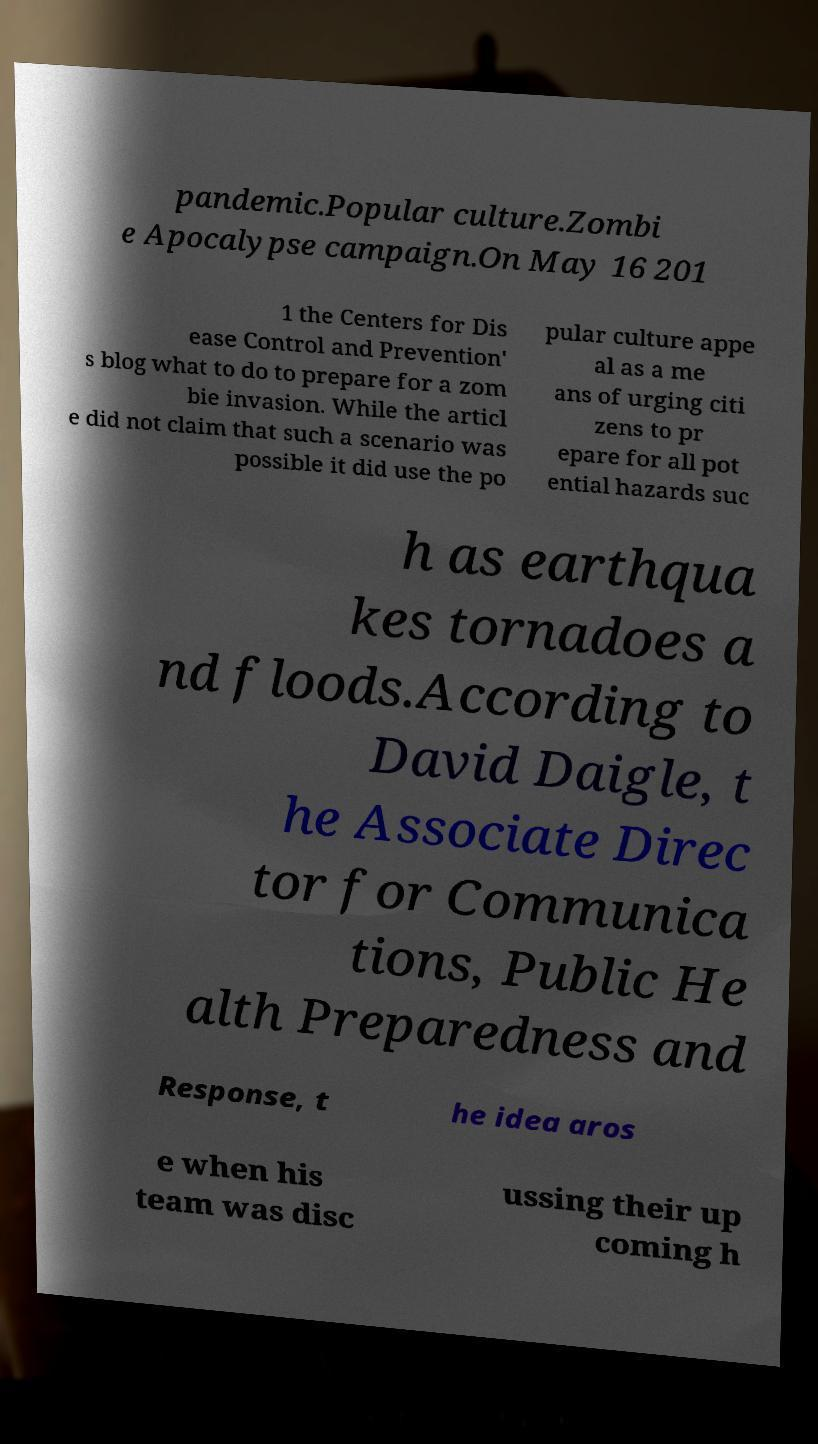Can you read and provide the text displayed in the image?This photo seems to have some interesting text. Can you extract and type it out for me? pandemic.Popular culture.Zombi e Apocalypse campaign.On May 16 201 1 the Centers for Dis ease Control and Prevention' s blog what to do to prepare for a zom bie invasion. While the articl e did not claim that such a scenario was possible it did use the po pular culture appe al as a me ans of urging citi zens to pr epare for all pot ential hazards suc h as earthqua kes tornadoes a nd floods.According to David Daigle, t he Associate Direc tor for Communica tions, Public He alth Preparedness and Response, t he idea aros e when his team was disc ussing their up coming h 